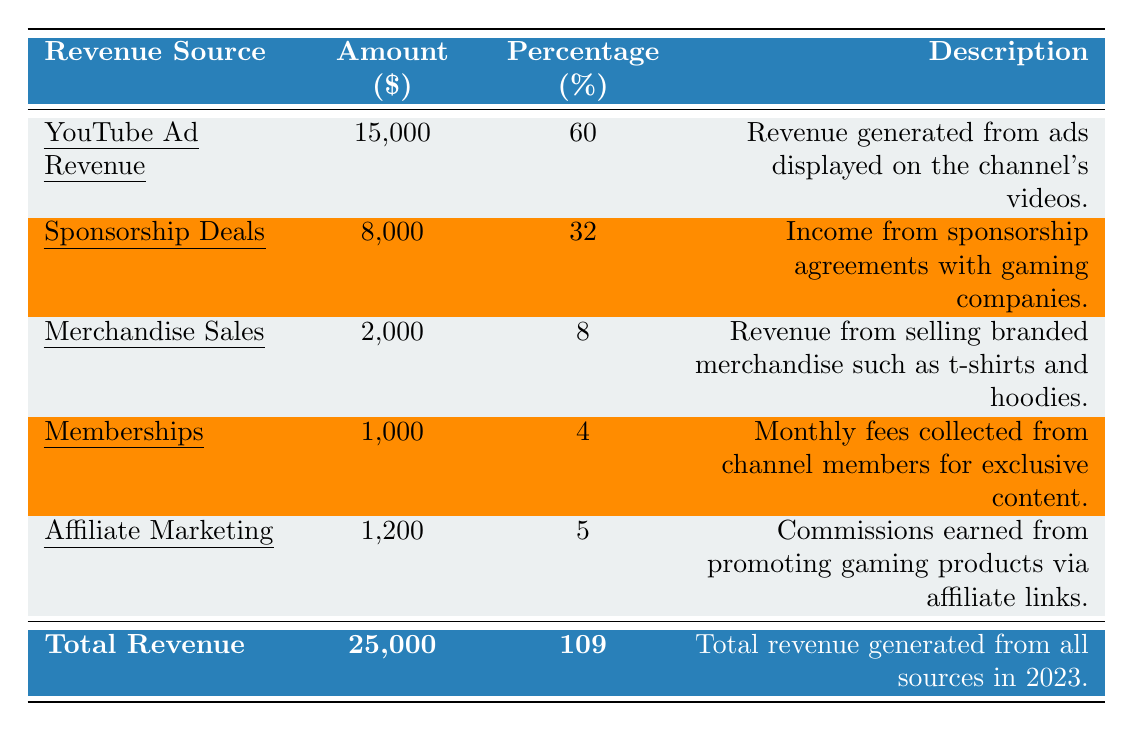What's the total revenue generated in 2023? The total revenue is provided in the table under "Total Revenue" as 25,000.
Answer: 25,000 What percentage of the total revenue comes from YouTube Ad Revenue? YouTube Ad Revenue is noted to contribute 60% of the total revenue.
Answer: 60% Which revenue source generated the least amount of income? Merchandise Sales generated the least amount of income at 2,000.
Answer: Merchandise Sales How much revenue was earned from Sponsorship Deals? The revenue from Sponsorship Deals is specified as 8,000.
Answer: 8,000 What is the combined revenue from Memberships and Affiliate Marketing? Memberships contribute 1,000 and Affiliate Marketing contributes 1,200; together (1,000 + 1,200) is 2,200.
Answer: 2,200 What percentage of the total revenue does Merchandise Sales represent? Merchandise Sales amount to 2,000 and its percentage is 8% of the total revenue.
Answer: 8% Is the total revenue less than 30,000? The total revenue of 25,000 is less than 30,000.
Answer: Yes Which revenue source accounts for more than 30% of the total revenue? YouTube Ad Revenue at 60% and Sponsorship Deals at 32% exceed 30%.
Answer: YouTube Ad Revenue and Sponsorship Deals If YouTube Ad Revenue were to increase by 10%, how much would that amount to? A 10% increase on 15,000 results in an additional 1,500, giving a total of 16,500.
Answer: 16,500 How does the percentage from Affiliate Marketing compare to that of Memberships? Affiliate Marketing at 5% is greater than Memberships at 4%.
Answer: Affiliate Marketing is greater 